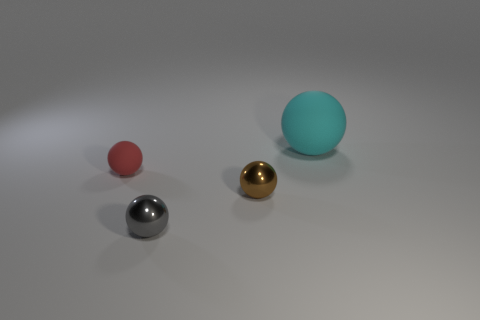How many other things are made of the same material as the small brown ball?
Provide a short and direct response. 1. How many gray objects are behind the matte sphere that is to the left of the tiny gray object?
Your answer should be compact. 0. Is there any other thing that has the same shape as the small gray shiny thing?
Keep it short and to the point. Yes. Is the color of the matte sphere to the left of the gray metal object the same as the matte object that is behind the tiny red thing?
Your answer should be compact. No. Are there fewer rubber spheres than small purple rubber cubes?
Provide a succinct answer. No. What shape is the rubber thing that is left of the rubber object that is behind the small red rubber object?
Make the answer very short. Sphere. Is there anything else that is the same size as the gray metal thing?
Offer a terse response. Yes. The red matte object to the left of the metallic ball that is in front of the small metallic sphere behind the gray thing is what shape?
Provide a short and direct response. Sphere. What number of objects are things on the left side of the big sphere or matte balls that are in front of the large cyan matte ball?
Keep it short and to the point. 3. Do the red rubber thing and the matte thing behind the red matte object have the same size?
Give a very brief answer. No. 